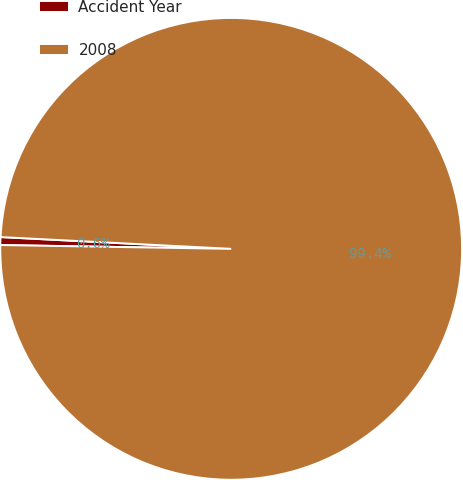Convert chart to OTSL. <chart><loc_0><loc_0><loc_500><loc_500><pie_chart><fcel>Accident Year<fcel>2008<nl><fcel>0.55%<fcel>99.45%<nl></chart> 